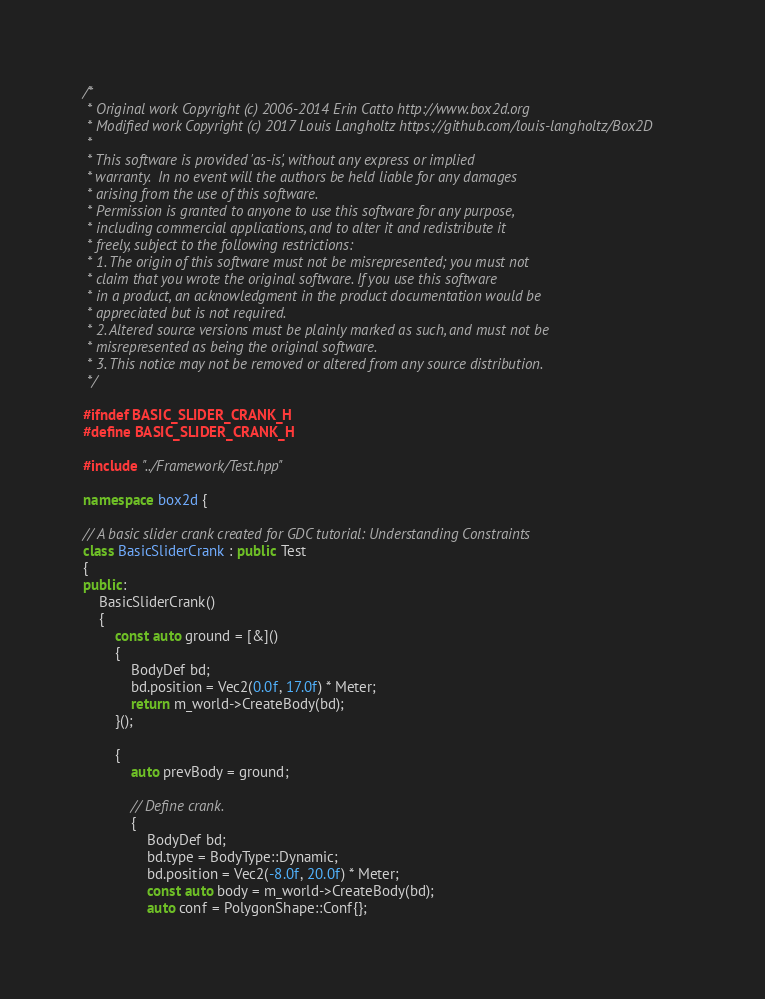Convert code to text. <code><loc_0><loc_0><loc_500><loc_500><_C++_>/*
 * Original work Copyright (c) 2006-2014 Erin Catto http://www.box2d.org
 * Modified work Copyright (c) 2017 Louis Langholtz https://github.com/louis-langholtz/Box2D
 *
 * This software is provided 'as-is', without any express or implied
 * warranty.  In no event will the authors be held liable for any damages
 * arising from the use of this software.
 * Permission is granted to anyone to use this software for any purpose,
 * including commercial applications, and to alter it and redistribute it
 * freely, subject to the following restrictions:
 * 1. The origin of this software must not be misrepresented; you must not
 * claim that you wrote the original software. If you use this software
 * in a product, an acknowledgment in the product documentation would be
 * appreciated but is not required.
 * 2. Altered source versions must be plainly marked as such, and must not be
 * misrepresented as being the original software.
 * 3. This notice may not be removed or altered from any source distribution.
 */

#ifndef BASIC_SLIDER_CRANK_H
#define BASIC_SLIDER_CRANK_H

#include "../Framework/Test.hpp"

namespace box2d {

// A basic slider crank created for GDC tutorial: Understanding Constraints
class BasicSliderCrank : public Test
{
public:
    BasicSliderCrank()
    {
        const auto ground = [&]()
        {
            BodyDef bd;
            bd.position = Vec2(0.0f, 17.0f) * Meter;
            return m_world->CreateBody(bd);
        }();
        
        {
            auto prevBody = ground;
            
            // Define crank.
            {
                BodyDef bd;
                bd.type = BodyType::Dynamic;
                bd.position = Vec2(-8.0f, 20.0f) * Meter;
                const auto body = m_world->CreateBody(bd);
                auto conf = PolygonShape::Conf{};</code> 